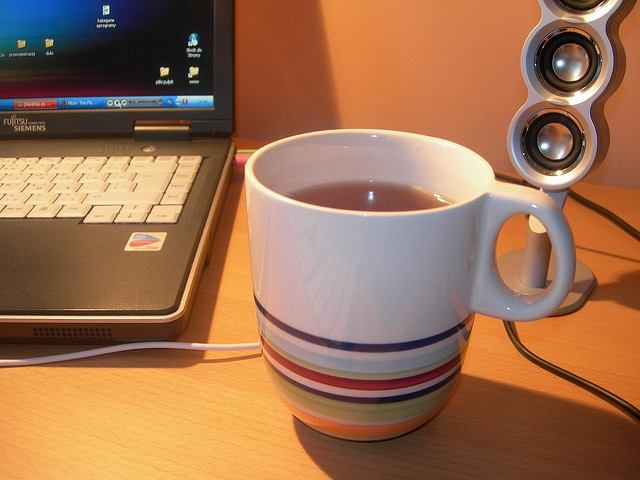Describe the objects in this image and their specific colors. I can see cup in blue, darkgray, pink, brown, and gray tones and laptop in blue, black, tan, maroon, and gray tones in this image. 